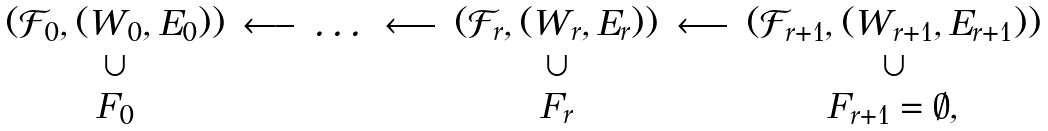<formula> <loc_0><loc_0><loc_500><loc_500>\begin{array} { c c c c c c c } ( { \mathcal { F } } _ { 0 } , ( W _ { 0 } , E _ { 0 } ) ) & \longleftarrow & \dots & \longleftarrow & ( { \mathcal { F } } _ { r } , ( W _ { r } , E _ { r } ) ) & \longleftarrow & ( { \mathcal { F } } _ { r + 1 } , ( W _ { r + 1 } , E _ { r + 1 } ) ) \\ \cup & & & & \cup & & \cup \\ F _ { 0 } & & & & F _ { r } & & F _ { r + 1 } = \emptyset , \end{array}</formula> 